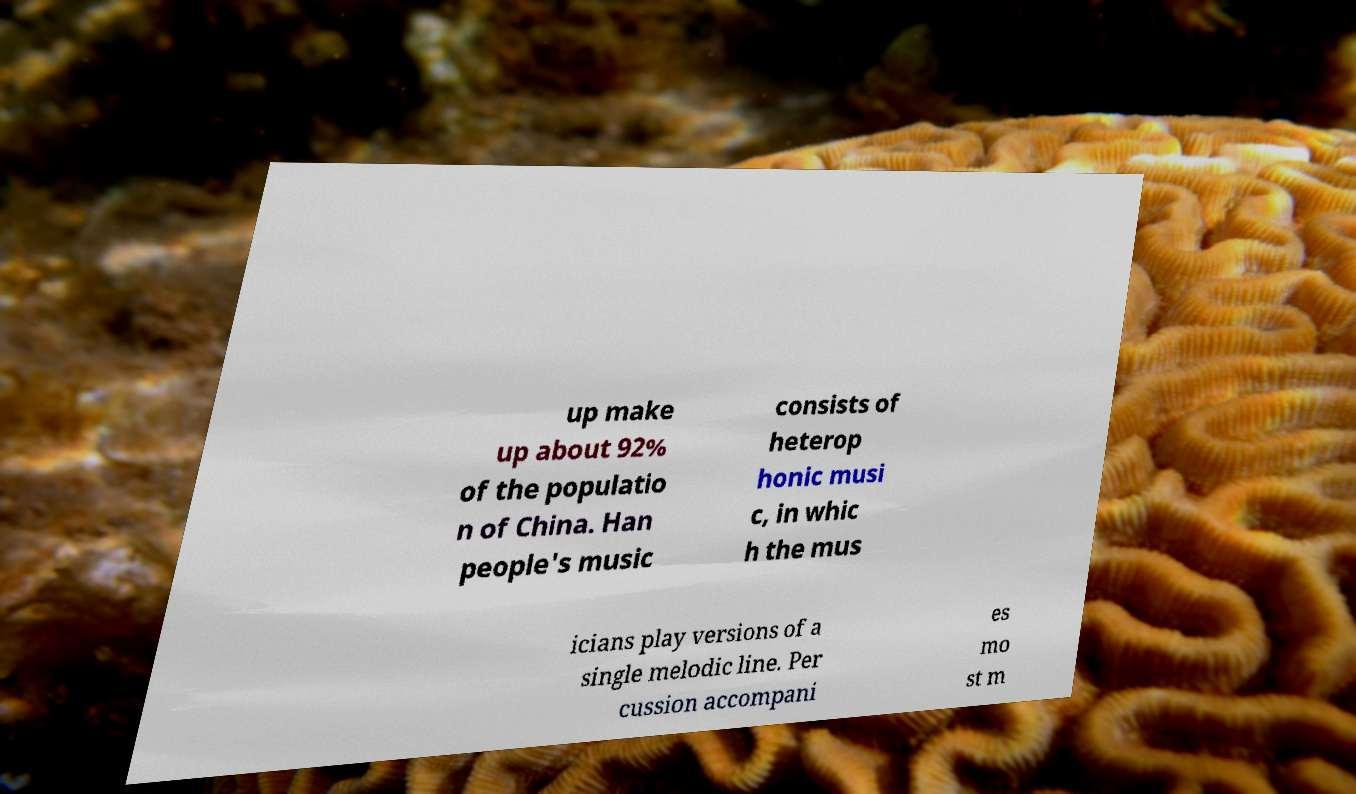There's text embedded in this image that I need extracted. Can you transcribe it verbatim? up make up about 92% of the populatio n of China. Han people's music consists of heterop honic musi c, in whic h the mus icians play versions of a single melodic line. Per cussion accompani es mo st m 